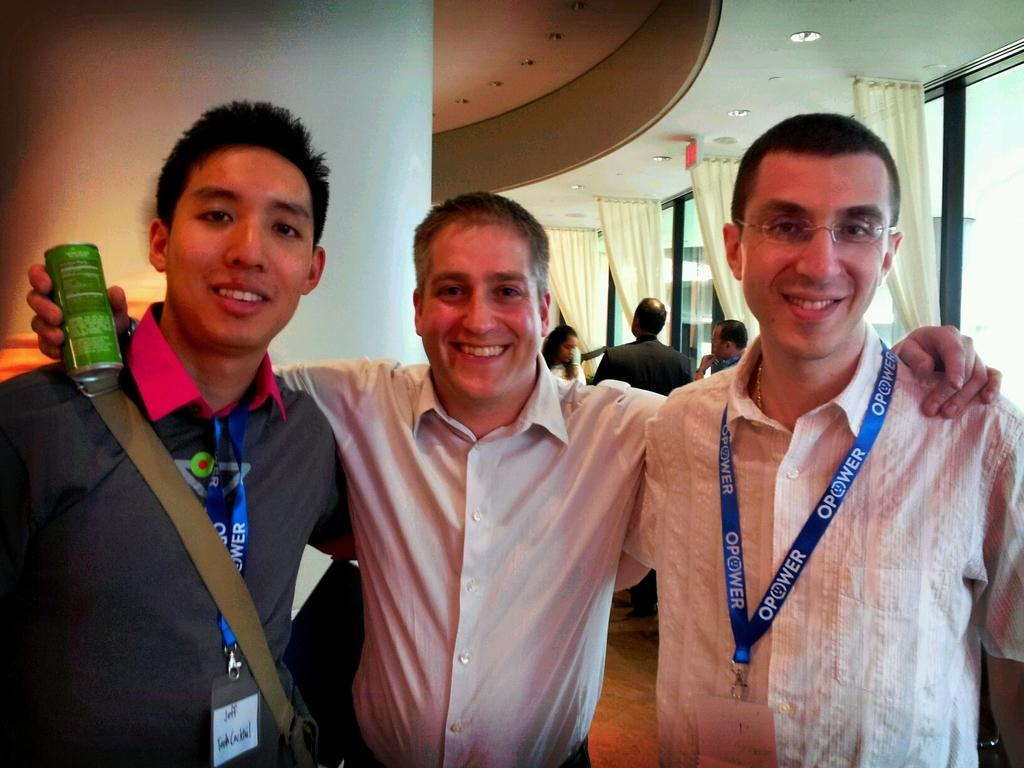<image>
Give a short and clear explanation of the subsequent image. 3 guys getting their photo taken with one of them wearing Opower tag around his neck. 